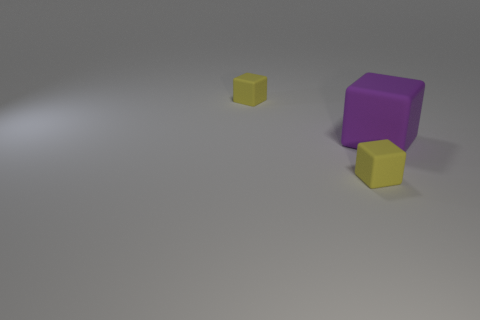What is the color of the small matte object on the right side of the yellow matte object that is on the left side of the small yellow matte object in front of the big rubber object?
Ensure brevity in your answer.  Yellow. Do the yellow thing in front of the purple block and the big block have the same material?
Offer a terse response. Yes. Is there a cube of the same color as the large object?
Your answer should be compact. No. Are any green objects visible?
Keep it short and to the point. No. Is the size of the yellow block in front of the purple matte block the same as the purple matte block?
Keep it short and to the point. No. Is the number of yellow cubes less than the number of big matte blocks?
Offer a terse response. No. The yellow object in front of the small rubber object to the left of the rubber object that is in front of the purple rubber block is what shape?
Provide a succinct answer. Cube. Are there any other big blocks that have the same material as the large cube?
Provide a succinct answer. No. Do the small thing that is behind the big purple cube and the matte block that is in front of the big cube have the same color?
Your answer should be very brief. Yes. Are there fewer tiny matte blocks in front of the big rubber block than gray balls?
Your answer should be compact. No. 